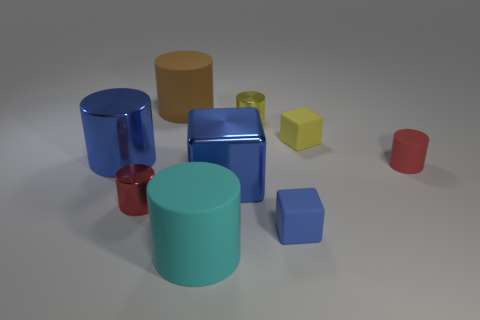There is a cube that is left of the yellow metallic cylinder behind the cyan rubber cylinder that is in front of the yellow cylinder; what is its size? The cube in question, positioned to the left of the yellow metallic cylinder and behind the cyan rubber one, is relatively large when compared to the cylinders. 